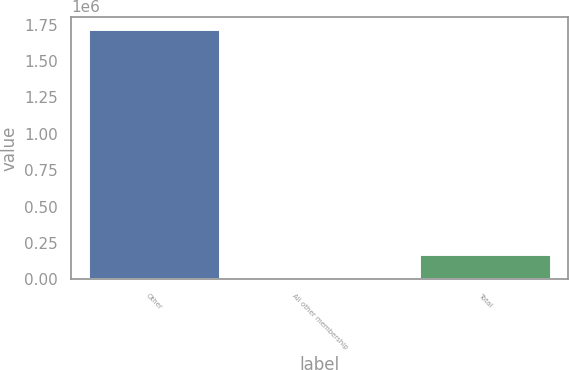Convert chart. <chart><loc_0><loc_0><loc_500><loc_500><bar_chart><fcel>Other<fcel>All other membership<fcel>Total<nl><fcel>1.7191e+06<fcel>100<fcel>172000<nl></chart> 